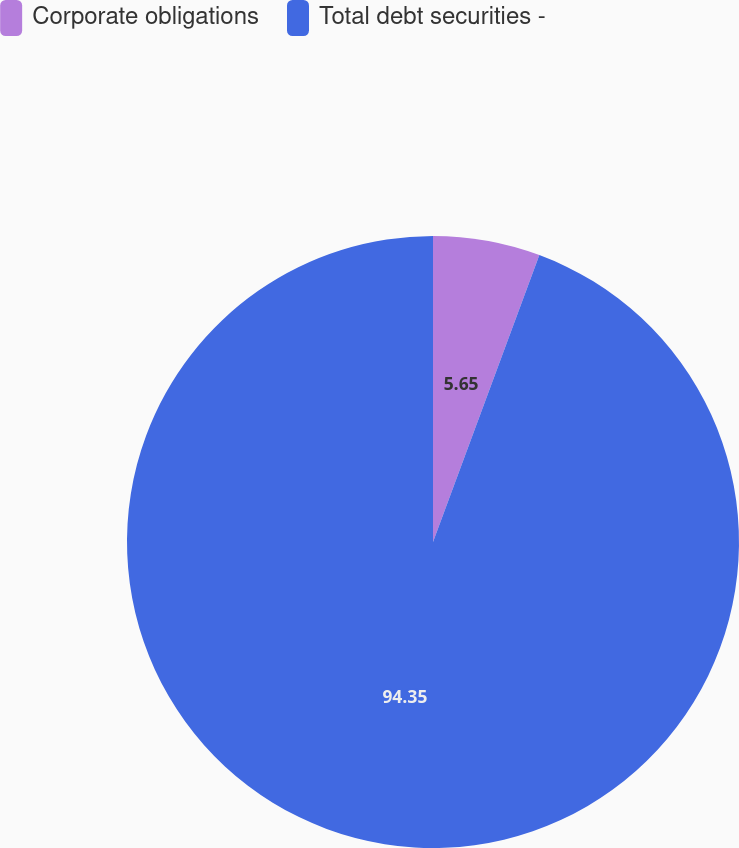Convert chart to OTSL. <chart><loc_0><loc_0><loc_500><loc_500><pie_chart><fcel>Corporate obligations<fcel>Total debt securities -<nl><fcel>5.65%<fcel>94.35%<nl></chart> 